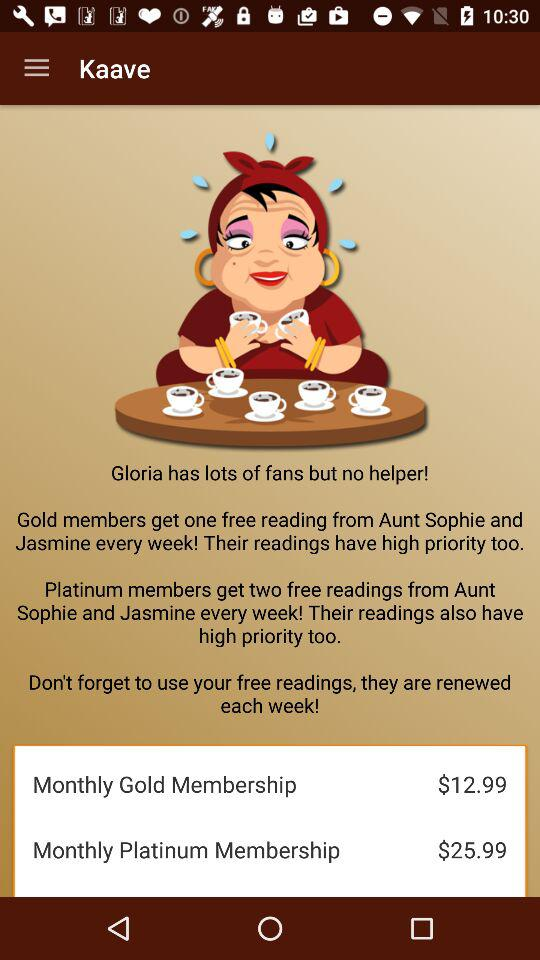How many more free readings do platinum members get compared to gold members?
Answer the question using a single word or phrase. 1 